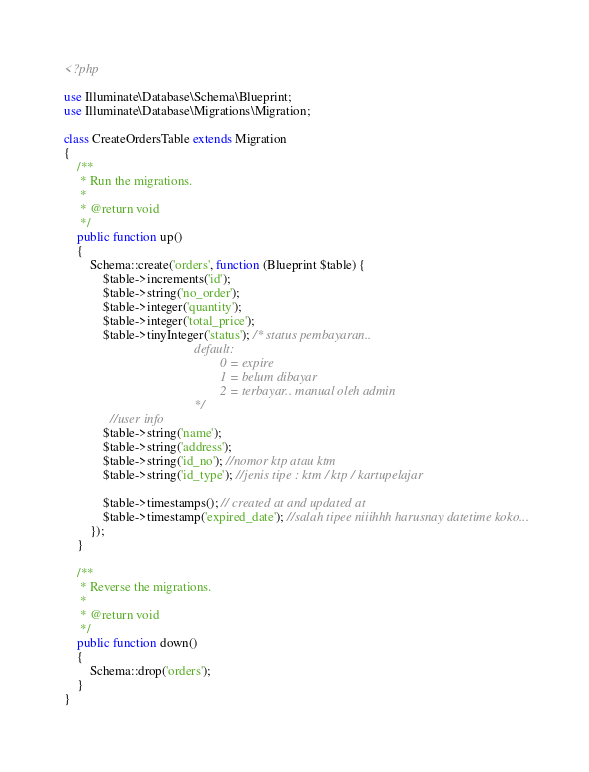Convert code to text. <code><loc_0><loc_0><loc_500><loc_500><_PHP_><?php

use Illuminate\Database\Schema\Blueprint;
use Illuminate\Database\Migrations\Migration;

class CreateOrdersTable extends Migration
{
    /**
     * Run the migrations.
     *
     * @return void
     */
    public function up()
    {
        Schema::create('orders', function (Blueprint $table) {
            $table->increments('id');
            $table->string('no_order');
            $table->integer('quantity');
            $table->integer('total_price');
            $table->tinyInteger('status'); /* status pembayaran..
                                        default:
                                                0 = expire
                                                1 = belum dibayar
                                                2 = terbayar.. manual oleh admin
                                        */
              //user info
            $table->string('name');
            $table->string('address');
            $table->string('id_no'); //nomor ktp atau ktm
            $table->string('id_type'); //jenis tipe : ktm / ktp / kartupelajar

            $table->timestamps(); // created at and updated at
            $table->timestamp('expired_date'); //salah tipee niiihhh harusnay datetime koko...
        });
    }

    /**
     * Reverse the migrations.
     *
     * @return void
     */
    public function down()
    {
        Schema::drop('orders');
    }
}
</code> 